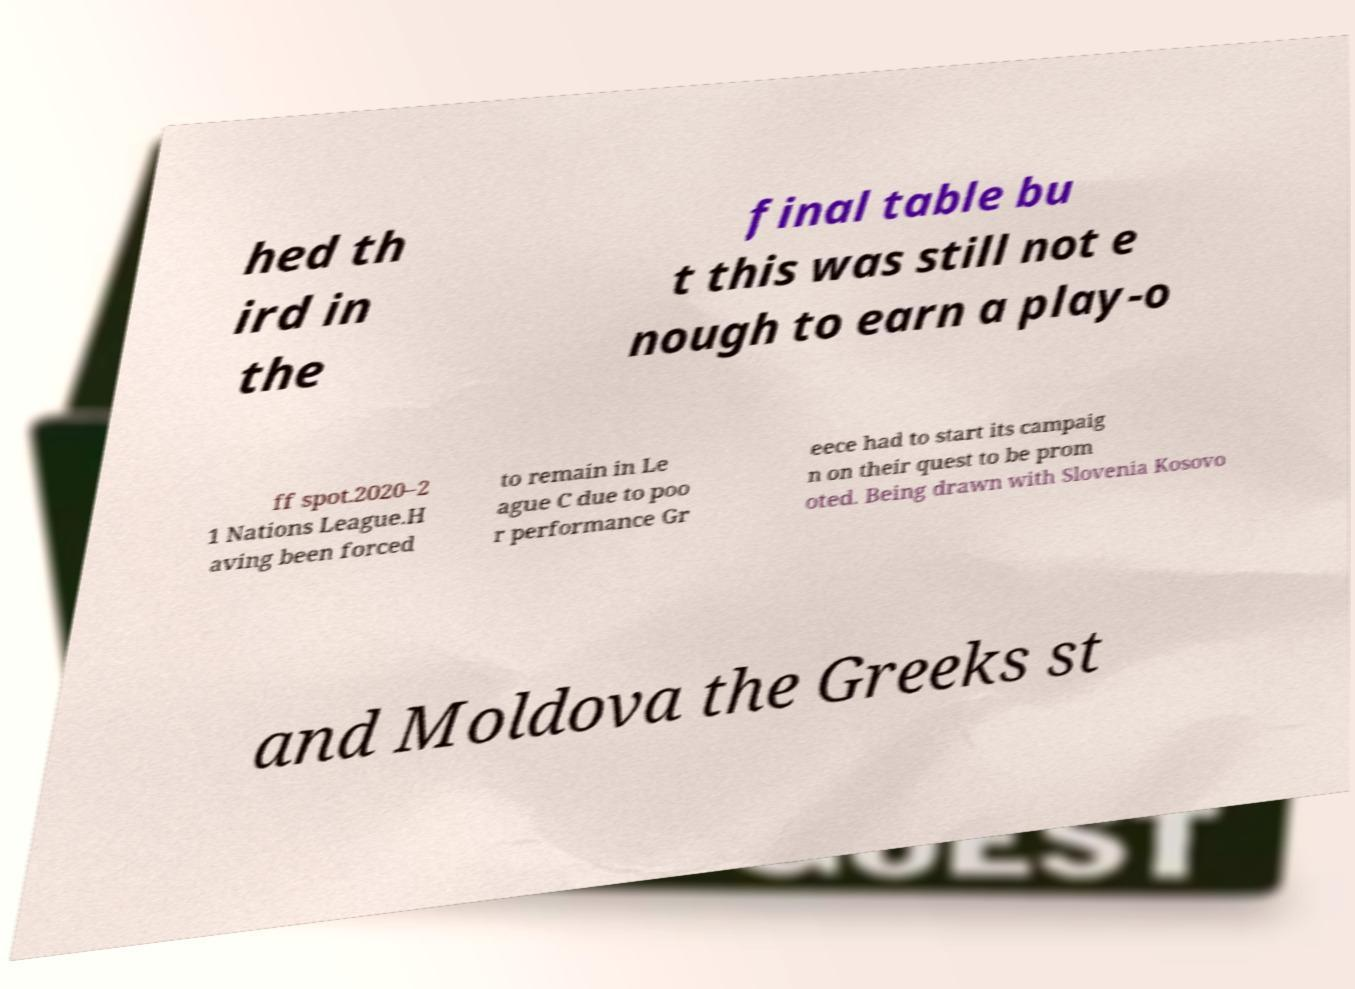Could you extract and type out the text from this image? hed th ird in the final table bu t this was still not e nough to earn a play-o ff spot.2020–2 1 Nations League.H aving been forced to remain in Le ague C due to poo r performance Gr eece had to start its campaig n on their quest to be prom oted. Being drawn with Slovenia Kosovo and Moldova the Greeks st 